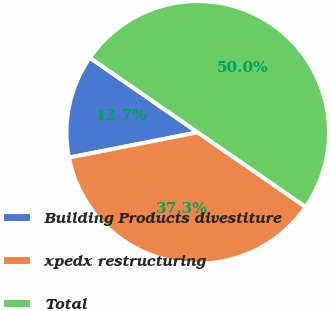Convert chart. <chart><loc_0><loc_0><loc_500><loc_500><pie_chart><fcel>Building Products divestiture<fcel>xpedx restructuring<fcel>Total<nl><fcel>12.71%<fcel>37.29%<fcel>50.0%<nl></chart> 